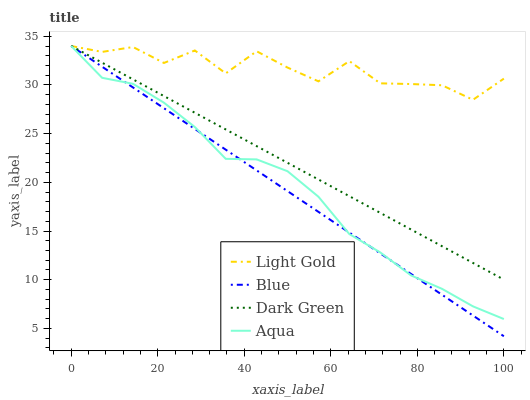Does Blue have the minimum area under the curve?
Answer yes or no. Yes. Does Light Gold have the maximum area under the curve?
Answer yes or no. Yes. Does Aqua have the minimum area under the curve?
Answer yes or no. No. Does Aqua have the maximum area under the curve?
Answer yes or no. No. Is Blue the smoothest?
Answer yes or no. Yes. Is Light Gold the roughest?
Answer yes or no. Yes. Is Aqua the smoothest?
Answer yes or no. No. Is Aqua the roughest?
Answer yes or no. No. Does Blue have the lowest value?
Answer yes or no. Yes. Does Aqua have the lowest value?
Answer yes or no. No. Does Dark Green have the highest value?
Answer yes or no. Yes. Does Aqua intersect Dark Green?
Answer yes or no. Yes. Is Aqua less than Dark Green?
Answer yes or no. No. Is Aqua greater than Dark Green?
Answer yes or no. No. 